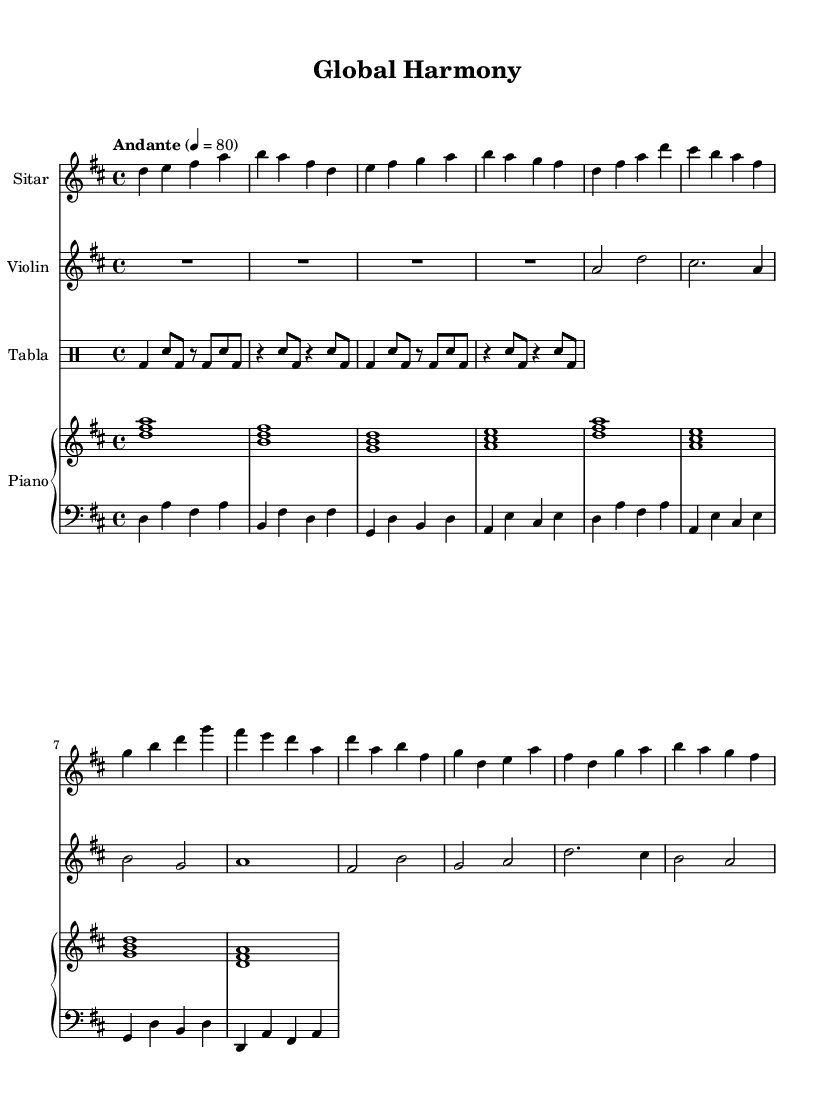What is the key signature of this music? The key signature is D major, which has two sharps (F# and C#). We can determine this by looking at the key declaration at the beginning of the staff, which is indicated by \key d \major.
Answer: D major What is the time signature of this piece? The time signature is 4/4, which is indicated at the beginning of the score and shows that there are four beats in each measure. This can be identified from the \time 4/4 statement.
Answer: 4/4 What is the tempo marking for this music? The tempo marking is Andante, which generally suggests a moderate pace. This indication is given at the start, aligned with the tempo notation 4 = 80, suggesting the beats per minute.
Answer: Andante Which instruments are included in this score? The instruments include Sitar, Violin, Tabla, and Piano. Each instrument is specifically referenced in the staff names shown at the beginning of each part.
Answer: Sitar, Violin, Tabla, Piano How many measures are in the Sitar part? There are ten measures in the Sitar part. By counting the distinct sets of bar lines, one can tally the number of measures easily shown in the staff.
Answer: 10 Which rhythmic pattern is repeated in the Tabla part? The rhythmic pattern in the Tabla part consists of a combination of bass drum and snare hits, specifically a pattern repeated twice indicated by "bd" for bass drum and "sn" for snare.
Answer: bd sn In what ways does this piece reflect Indo-Western fusion? This piece reflects Indo-Western fusion through the combination of traditional Indian instruments (Sitar, Tabla) with Western classical forms and harmonies presented in the Violin and Piano sections. The blend of modal scales showcases cultural integration.
Answer: Traditional instruments 